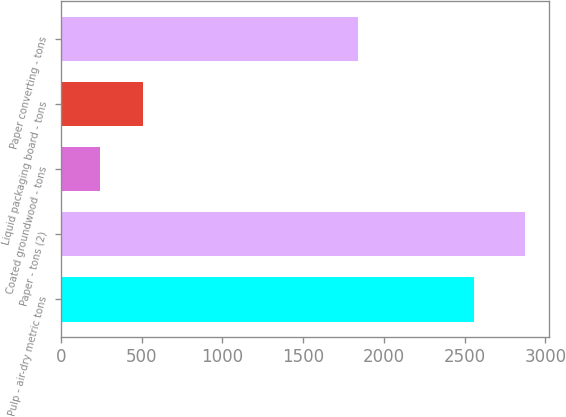Convert chart. <chart><loc_0><loc_0><loc_500><loc_500><bar_chart><fcel>Pulp - air-dry metric tons<fcel>Paper - tons (2)<fcel>Coated groundwood - tons<fcel>Liquid packaging board - tons<fcel>Paper converting - tons<nl><fcel>2558<fcel>2876<fcel>243<fcel>506.3<fcel>1839<nl></chart> 